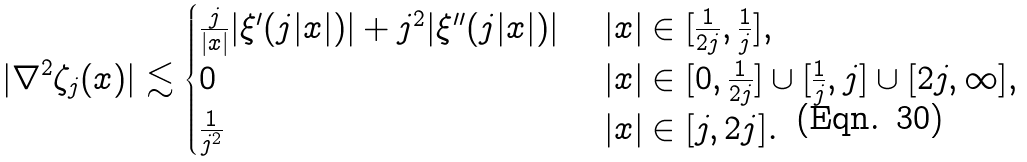<formula> <loc_0><loc_0><loc_500><loc_500>| \nabla ^ { 2 } \zeta _ { j } ( x ) | \lesssim \begin{cases} \frac { j } { | x | } | \xi ^ { \prime } ( j | x | ) | + j ^ { 2 } | \xi ^ { \prime \prime } ( j | x | ) | & \ | x | \in [ \frac { 1 } { 2 j } , \frac { 1 } { j } ] , \\ 0 & \ | x | \in [ 0 , \frac { 1 } { 2 j } ] \cup [ \frac { 1 } { j } , j ] \cup [ 2 j , \infty ] , \\ \frac { 1 } { j ^ { 2 } } & \ | x | \in [ j , 2 j ] . \end{cases}</formula> 